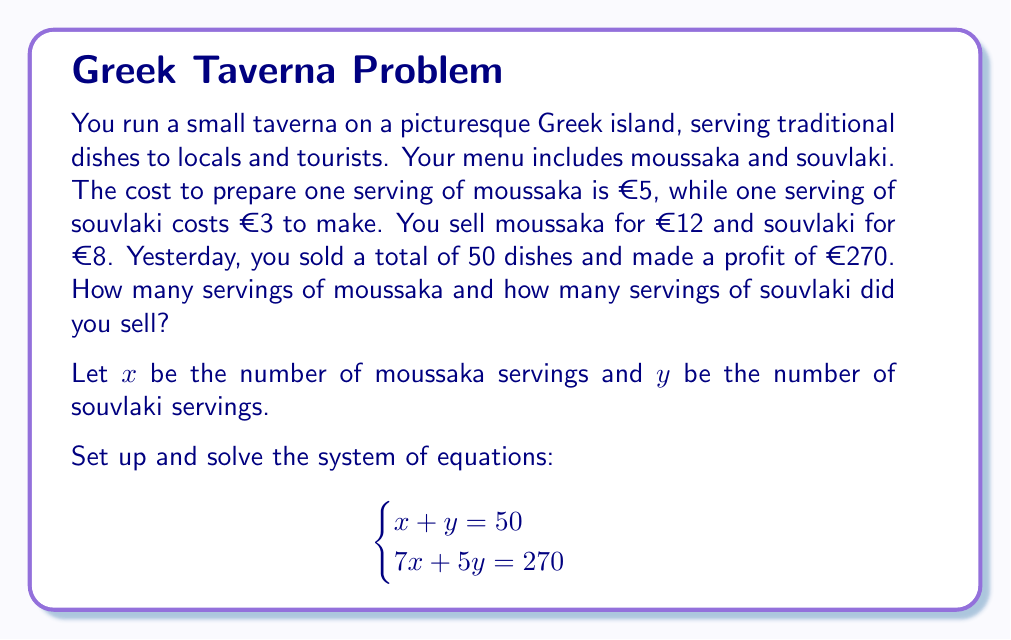Can you answer this question? Let's solve this system of equations step by step:

1) We have two equations:
   $$\begin{cases}
   x + y = 50 \quad \text{(Equation 1)}\\
   7x + 5y = 270 \quad \text{(Equation 2)}
   \end{cases}$$

2) Let's use the substitution method. From Equation 1, we can express $y$ in terms of $x$:
   $$y = 50 - x \quad \text{(Equation 3)}$$

3) Substitute this into Equation 2:
   $$7x + 5(50 - x) = 270$$

4) Simplify:
   $$7x + 250 - 5x = 270$$
   $$2x + 250 = 270$$

5) Solve for $x$:
   $$2x = 20$$
   $$x = 10$$

6) Now that we know $x$, we can find $y$ using Equation 3:
   $$y = 50 - 10 = 40$$

7) Let's verify our solution:
   - $x + y = 10 + 40 = 50$ (satisfies Equation 1)
   - $7x + 5y = 7(10) + 5(40) = 70 + 200 = 270$ (satisfies Equation 2)

Therefore, you sold 10 servings of moussaka and 40 servings of souvlaki.
Answer: 10 servings of moussaka and 40 servings of souvlaki 